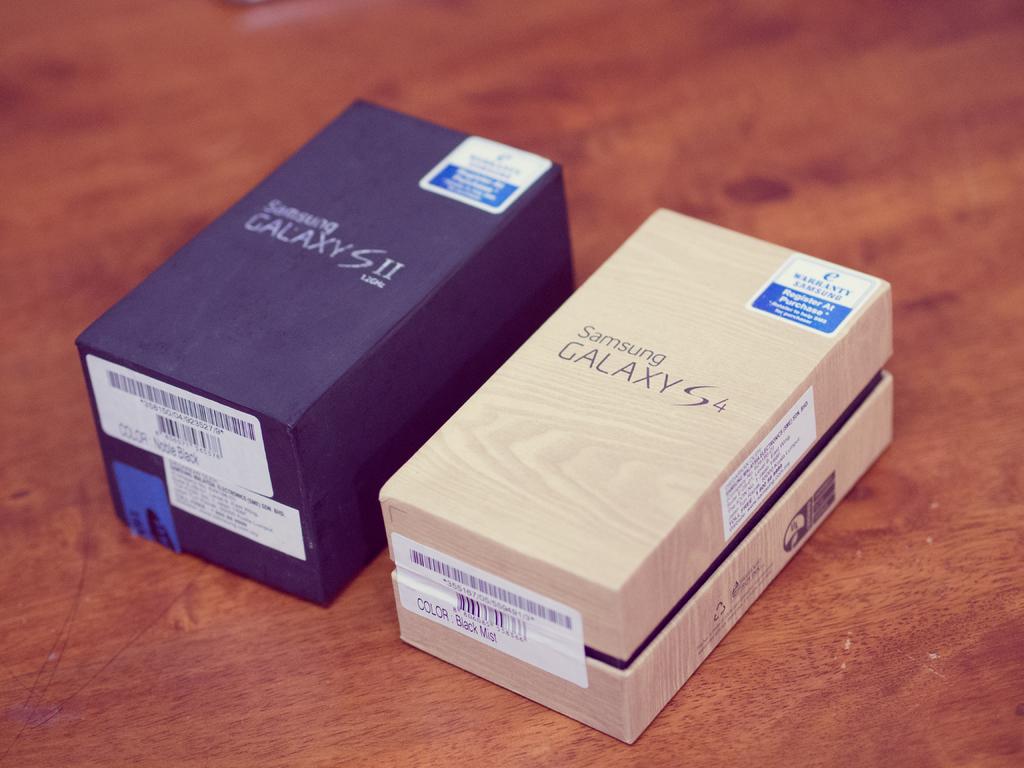What model is the phone on the right?
Provide a succinct answer. Galaxy s4. 